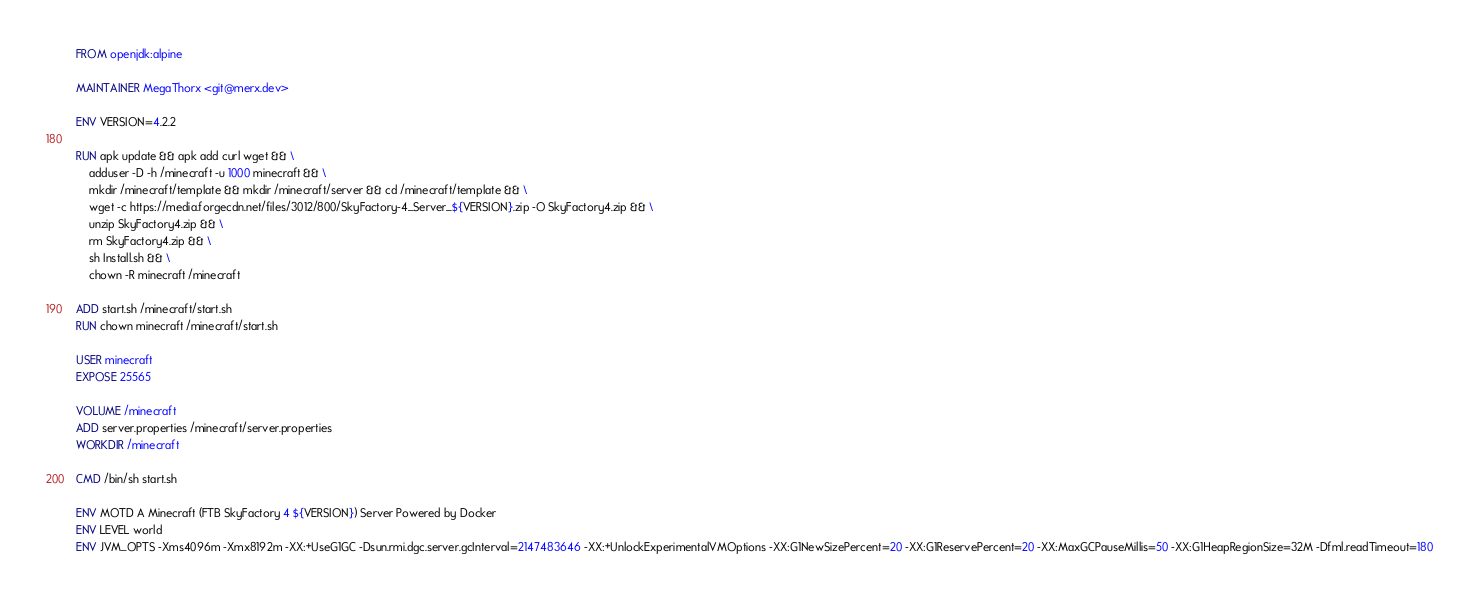<code> <loc_0><loc_0><loc_500><loc_500><_Dockerfile_>FROM openjdk:alpine

MAINTAINER MegaThorx <git@merx.dev>

ENV VERSION=4.2.2

RUN apk update && apk add curl wget && \
    adduser -D -h /minecraft -u 1000 minecraft && \
	mkdir /minecraft/template && mkdir /minecraft/server && cd /minecraft/template && \
	wget -c https://media.forgecdn.net/files/3012/800/SkyFactory-4_Server_${VERSION}.zip -O SkyFactory4.zip && \
	unzip SkyFactory4.zip && \
	rm SkyFactory4.zip && \
	sh Install.sh && \
	chown -R minecraft /minecraft

ADD start.sh /minecraft/start.sh
RUN chown minecraft /minecraft/start.sh

USER minecraft
EXPOSE 25565

VOLUME /minecraft
ADD server.properties /minecraft/server.properties
WORKDIR /minecraft

CMD /bin/sh start.sh

ENV MOTD A Minecraft (FTB SkyFactory 4 ${VERSION}) Server Powered by Docker
ENV LEVEL world
ENV JVM_OPTS -Xms4096m -Xmx8192m -XX:+UseG1GC -Dsun.rmi.dgc.server.gcInterval=2147483646 -XX:+UnlockExperimentalVMOptions -XX:G1NewSizePercent=20 -XX:G1ReservePercent=20 -XX:MaxGCPauseMillis=50 -XX:G1HeapRegionSize=32M -Dfml.readTimeout=180
</code> 